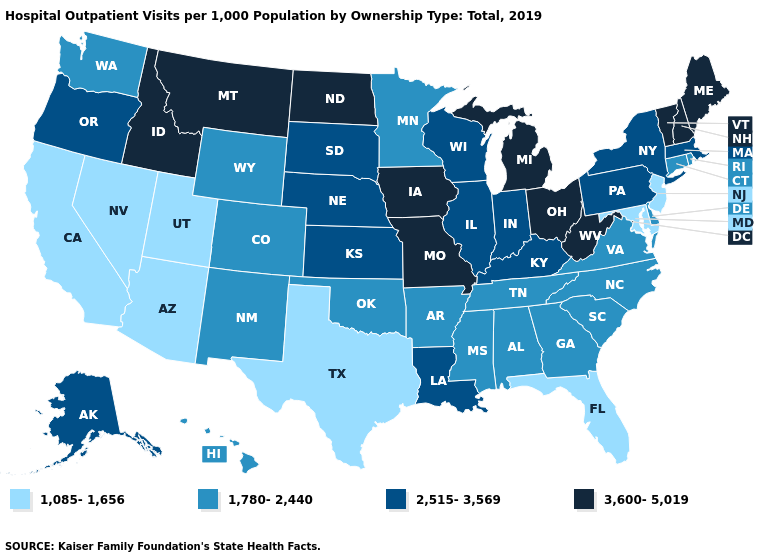Does Virginia have the lowest value in the South?
Concise answer only. No. What is the lowest value in states that border Utah?
Quick response, please. 1,085-1,656. Name the states that have a value in the range 1,085-1,656?
Concise answer only. Arizona, California, Florida, Maryland, Nevada, New Jersey, Texas, Utah. Which states have the lowest value in the USA?
Answer briefly. Arizona, California, Florida, Maryland, Nevada, New Jersey, Texas, Utah. Name the states that have a value in the range 1,085-1,656?
Short answer required. Arizona, California, Florida, Maryland, Nevada, New Jersey, Texas, Utah. Name the states that have a value in the range 1,780-2,440?
Quick response, please. Alabama, Arkansas, Colorado, Connecticut, Delaware, Georgia, Hawaii, Minnesota, Mississippi, New Mexico, North Carolina, Oklahoma, Rhode Island, South Carolina, Tennessee, Virginia, Washington, Wyoming. Among the states that border Oklahoma , does Arkansas have the highest value?
Short answer required. No. What is the value of Rhode Island?
Keep it brief. 1,780-2,440. Among the states that border Oregon , does Idaho have the highest value?
Write a very short answer. Yes. Name the states that have a value in the range 3,600-5,019?
Be succinct. Idaho, Iowa, Maine, Michigan, Missouri, Montana, New Hampshire, North Dakota, Ohio, Vermont, West Virginia. Among the states that border Nevada , which have the highest value?
Give a very brief answer. Idaho. Name the states that have a value in the range 2,515-3,569?
Keep it brief. Alaska, Illinois, Indiana, Kansas, Kentucky, Louisiana, Massachusetts, Nebraska, New York, Oregon, Pennsylvania, South Dakota, Wisconsin. Name the states that have a value in the range 1,780-2,440?
Quick response, please. Alabama, Arkansas, Colorado, Connecticut, Delaware, Georgia, Hawaii, Minnesota, Mississippi, New Mexico, North Carolina, Oklahoma, Rhode Island, South Carolina, Tennessee, Virginia, Washington, Wyoming. What is the value of Georgia?
Answer briefly. 1,780-2,440. What is the value of Oklahoma?
Give a very brief answer. 1,780-2,440. 